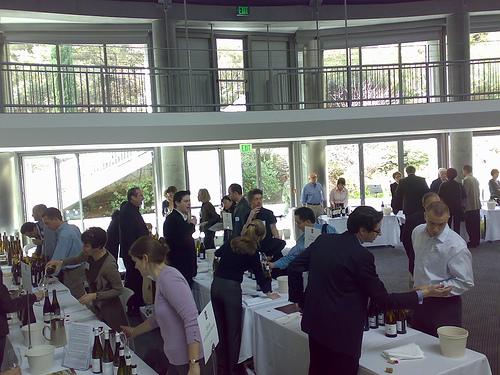Is this a wedding?
Be succinct. No. What color are the flowers?
Answer briefly. There are no flowers. How many people are in the image?
Answer briefly. 26. What kind of drinks do they have?
Short answer required. Wine. How many stories of the building are shown?
Give a very brief answer. 2. 